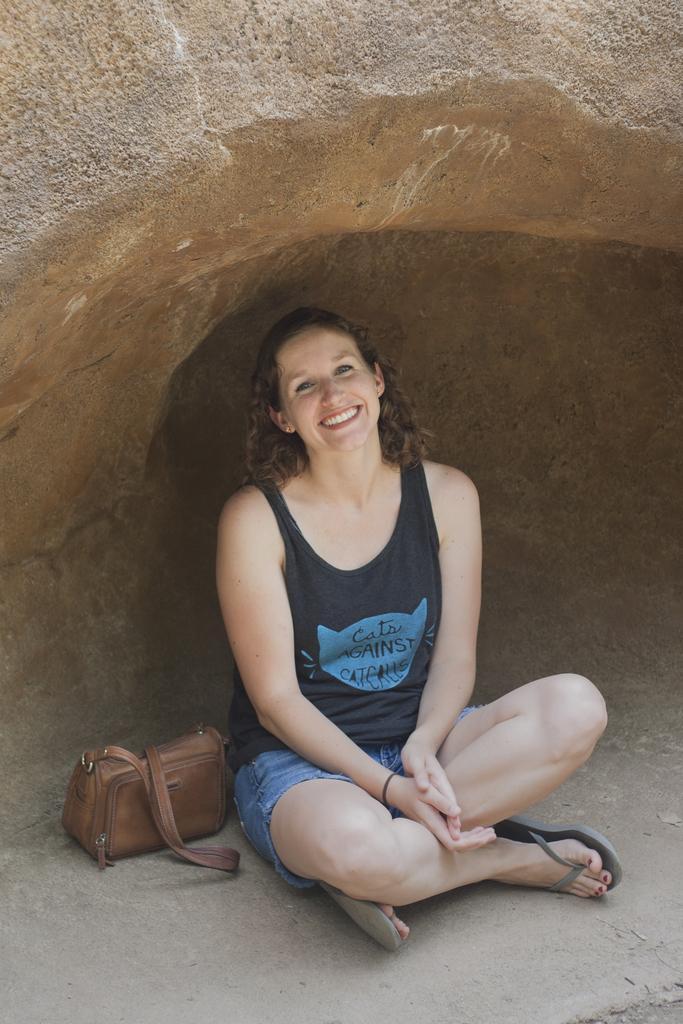Please provide a concise description of this image. In this image the woman is sitting on the floor and she is smiling. There is a bag. 